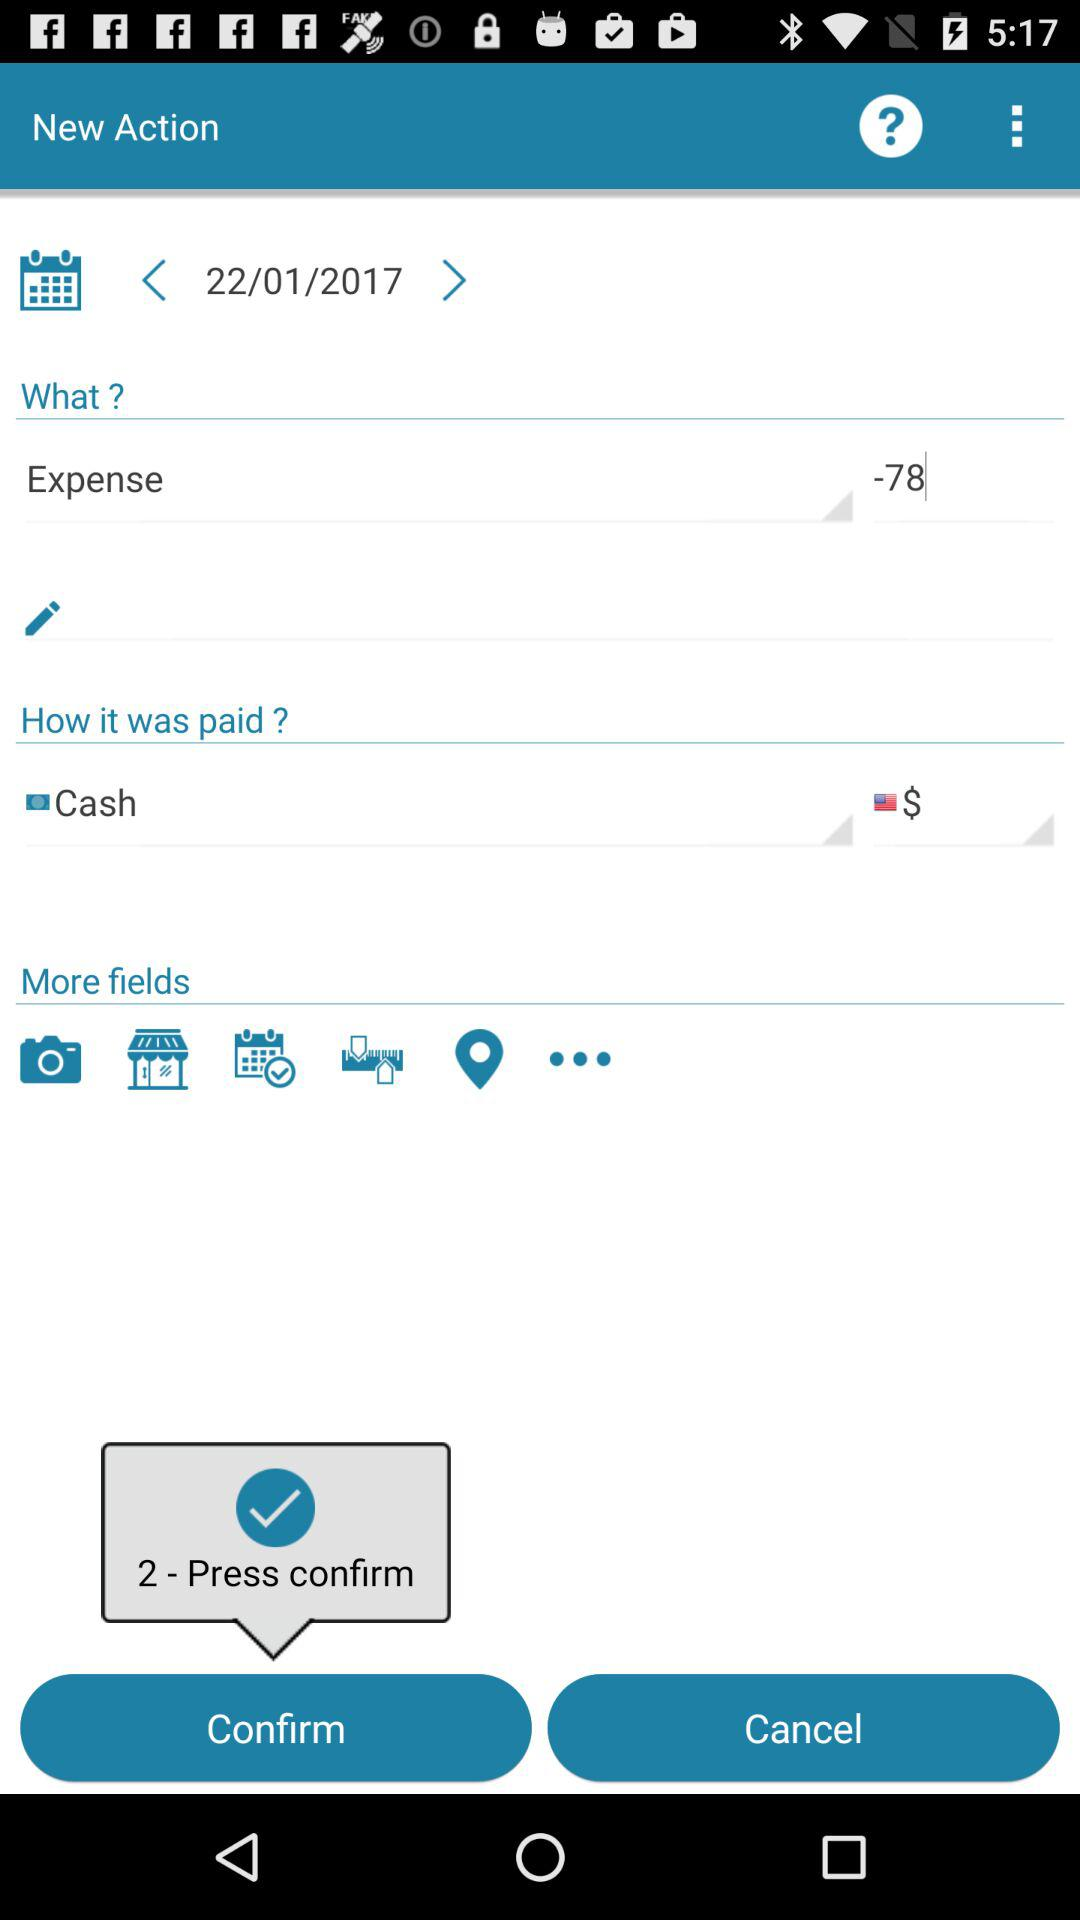What is the currency of the cash? The currency of the cash is dollars. 